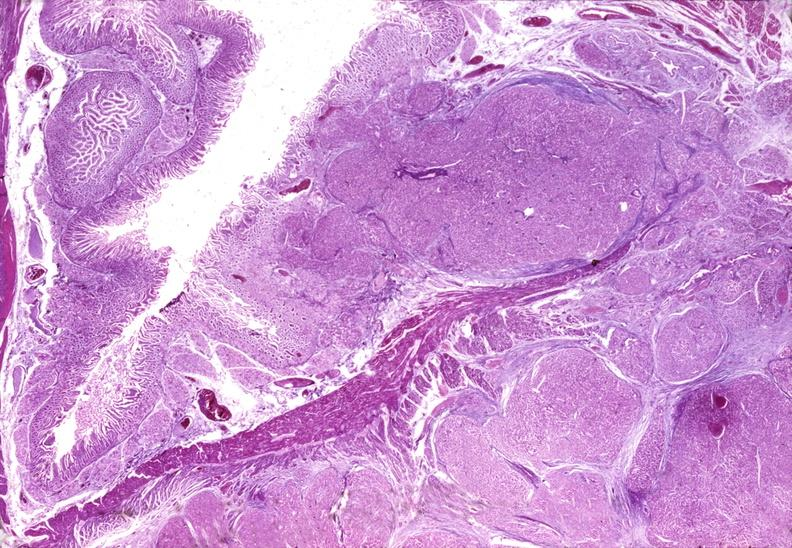does endometritis show islet cell carcinoma?
Answer the question using a single word or phrase. No 